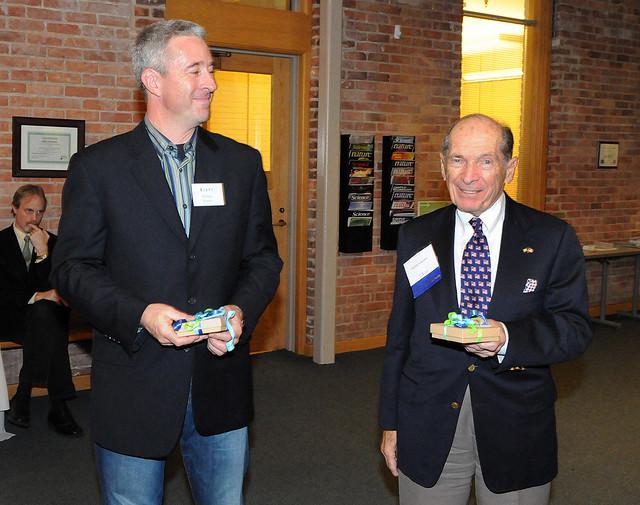Which man is older?
Write a very short answer. Right. How many people are wearing a tie?
Quick response, please. 2. Which man is dressed the most casual?
Short answer required. Man on left. 